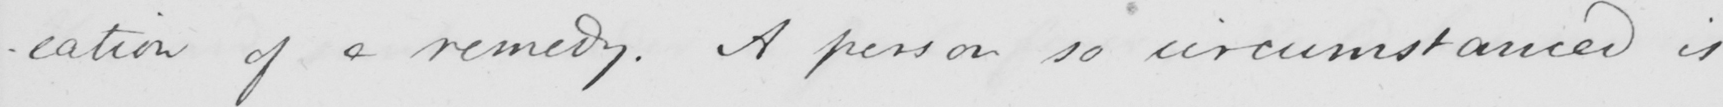What is written in this line of handwriting? -cation of a remedy . A person so circumstanced is 